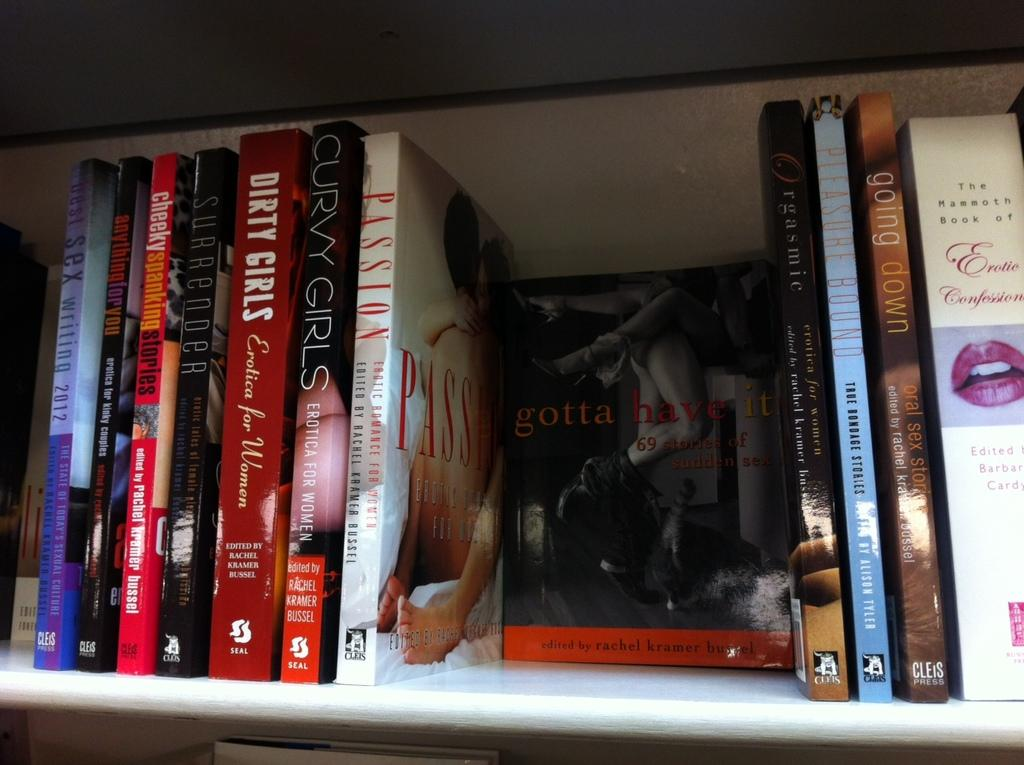<image>
Offer a succinct explanation of the picture presented. Book called gotta have it surrounded by other adult titles. 